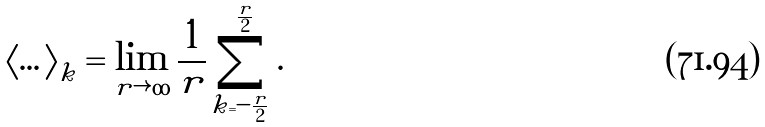Convert formula to latex. <formula><loc_0><loc_0><loc_500><loc_500>\left \langle \dots \right \rangle _ { k } = \lim _ { r \rightarrow \infty } \frac { 1 } { r } \sum _ { k = - \frac { r } { 2 } } ^ { \frac { r } { 2 } } .</formula> 